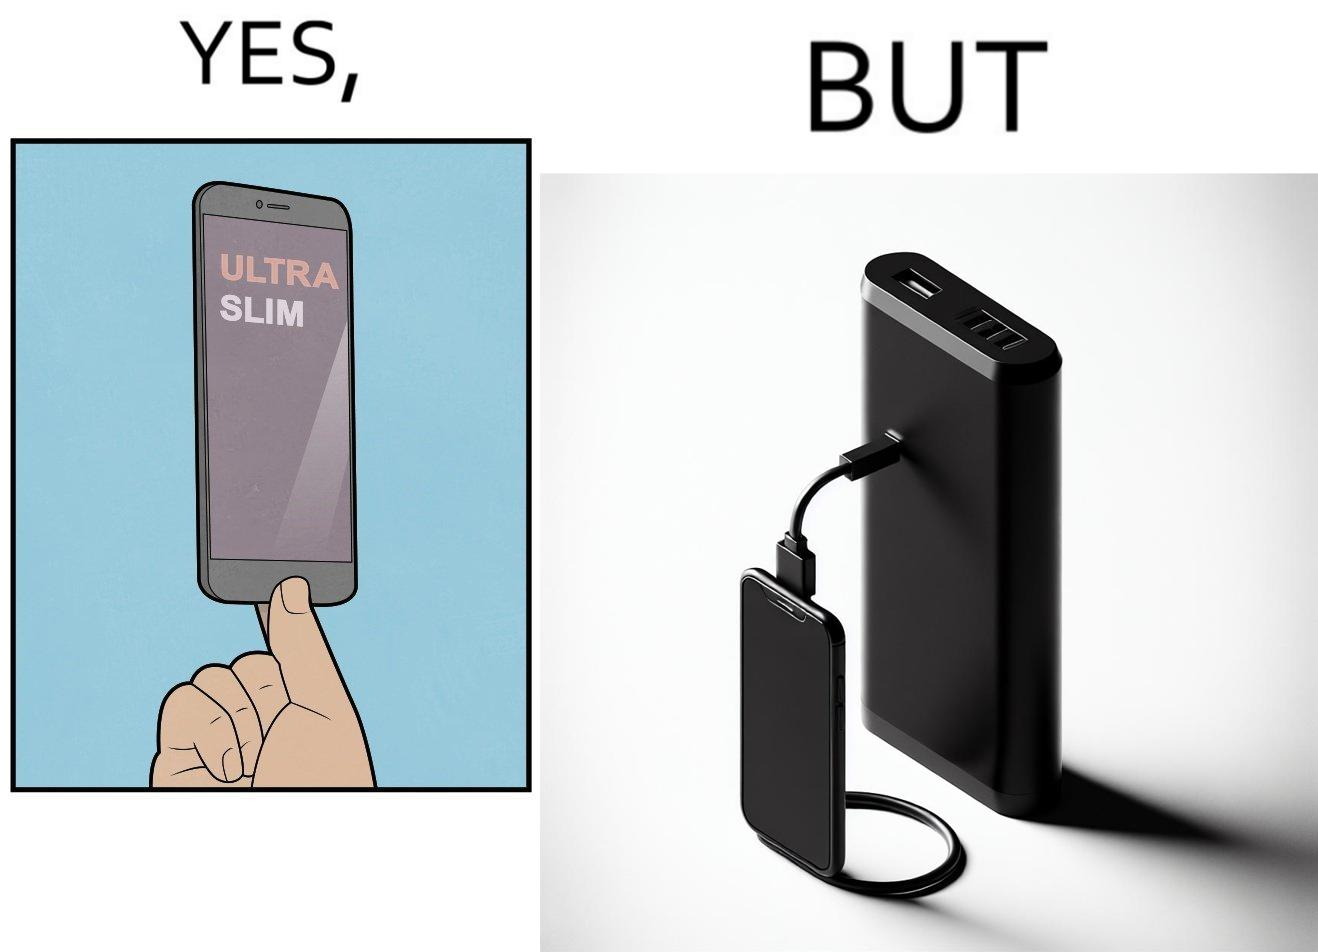What do you see in each half of this image? In the left part of the image: The image shows a hand holding a mobile phone with finger tips. The text on the screen of the mobile phone says "ULTRA SLIM".  The mobile phone is indeed very slim. In the right part of the image: The image shows a slim mobile phone connected to a thick,big and heavy power bank for charging the mobile phone. 